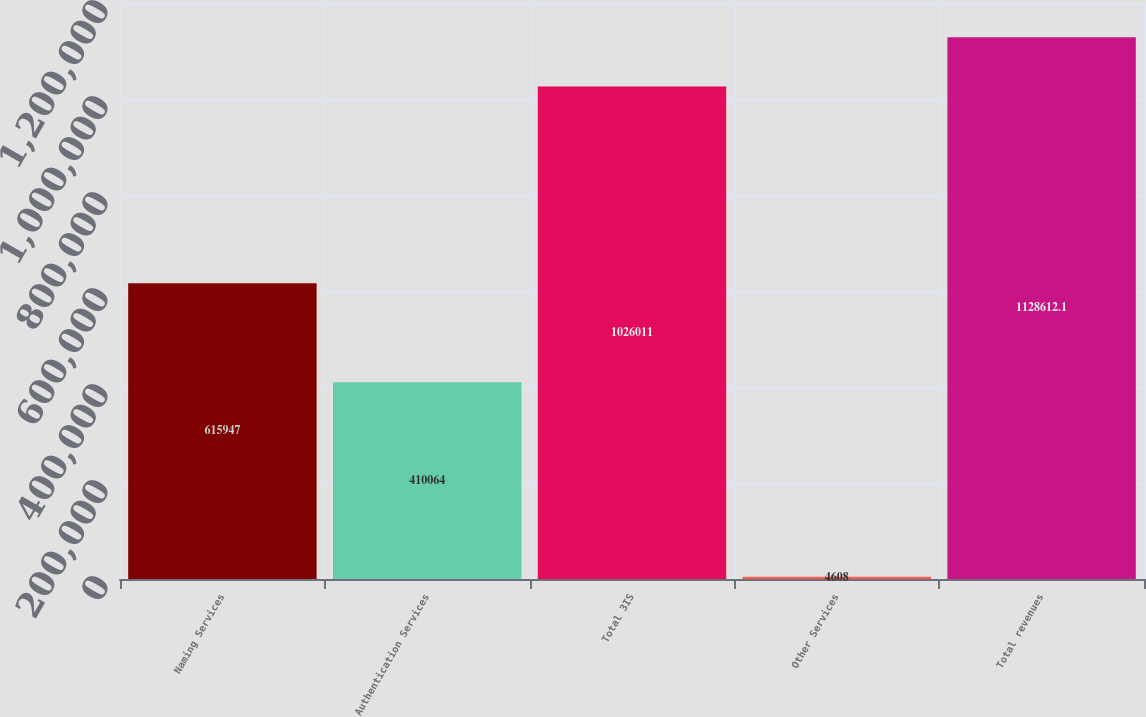Convert chart. <chart><loc_0><loc_0><loc_500><loc_500><bar_chart><fcel>Naming Services<fcel>Authentication Services<fcel>Total 3IS<fcel>Other Services<fcel>Total revenues<nl><fcel>615947<fcel>410064<fcel>1.02601e+06<fcel>4608<fcel>1.12861e+06<nl></chart> 